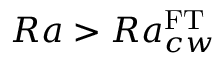<formula> <loc_0><loc_0><loc_500><loc_500>R a > R a _ { c w } ^ { F T }</formula> 